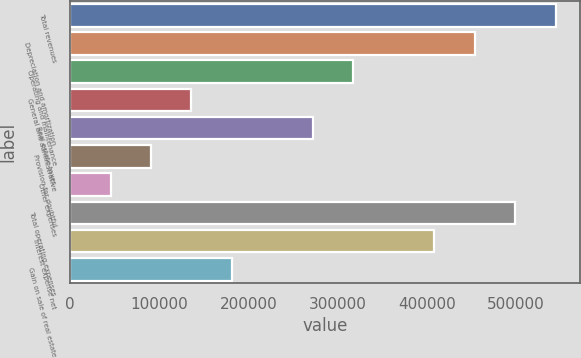Convert chart to OTSL. <chart><loc_0><loc_0><loc_500><loc_500><bar_chart><fcel>Total revenues<fcel>Depreciation and amortization<fcel>Operating and maintenance<fcel>General and administrative<fcel>Real estate taxes<fcel>Provision for doubtful<fcel>Other expenses<fcel>Total operating expenses<fcel>Interest expense net<fcel>Gain on sale of real estate<nl><fcel>544268<fcel>453580<fcel>317547<fcel>136171<fcel>272203<fcel>90826.4<fcel>45482.2<fcel>498924<fcel>408236<fcel>181515<nl></chart> 